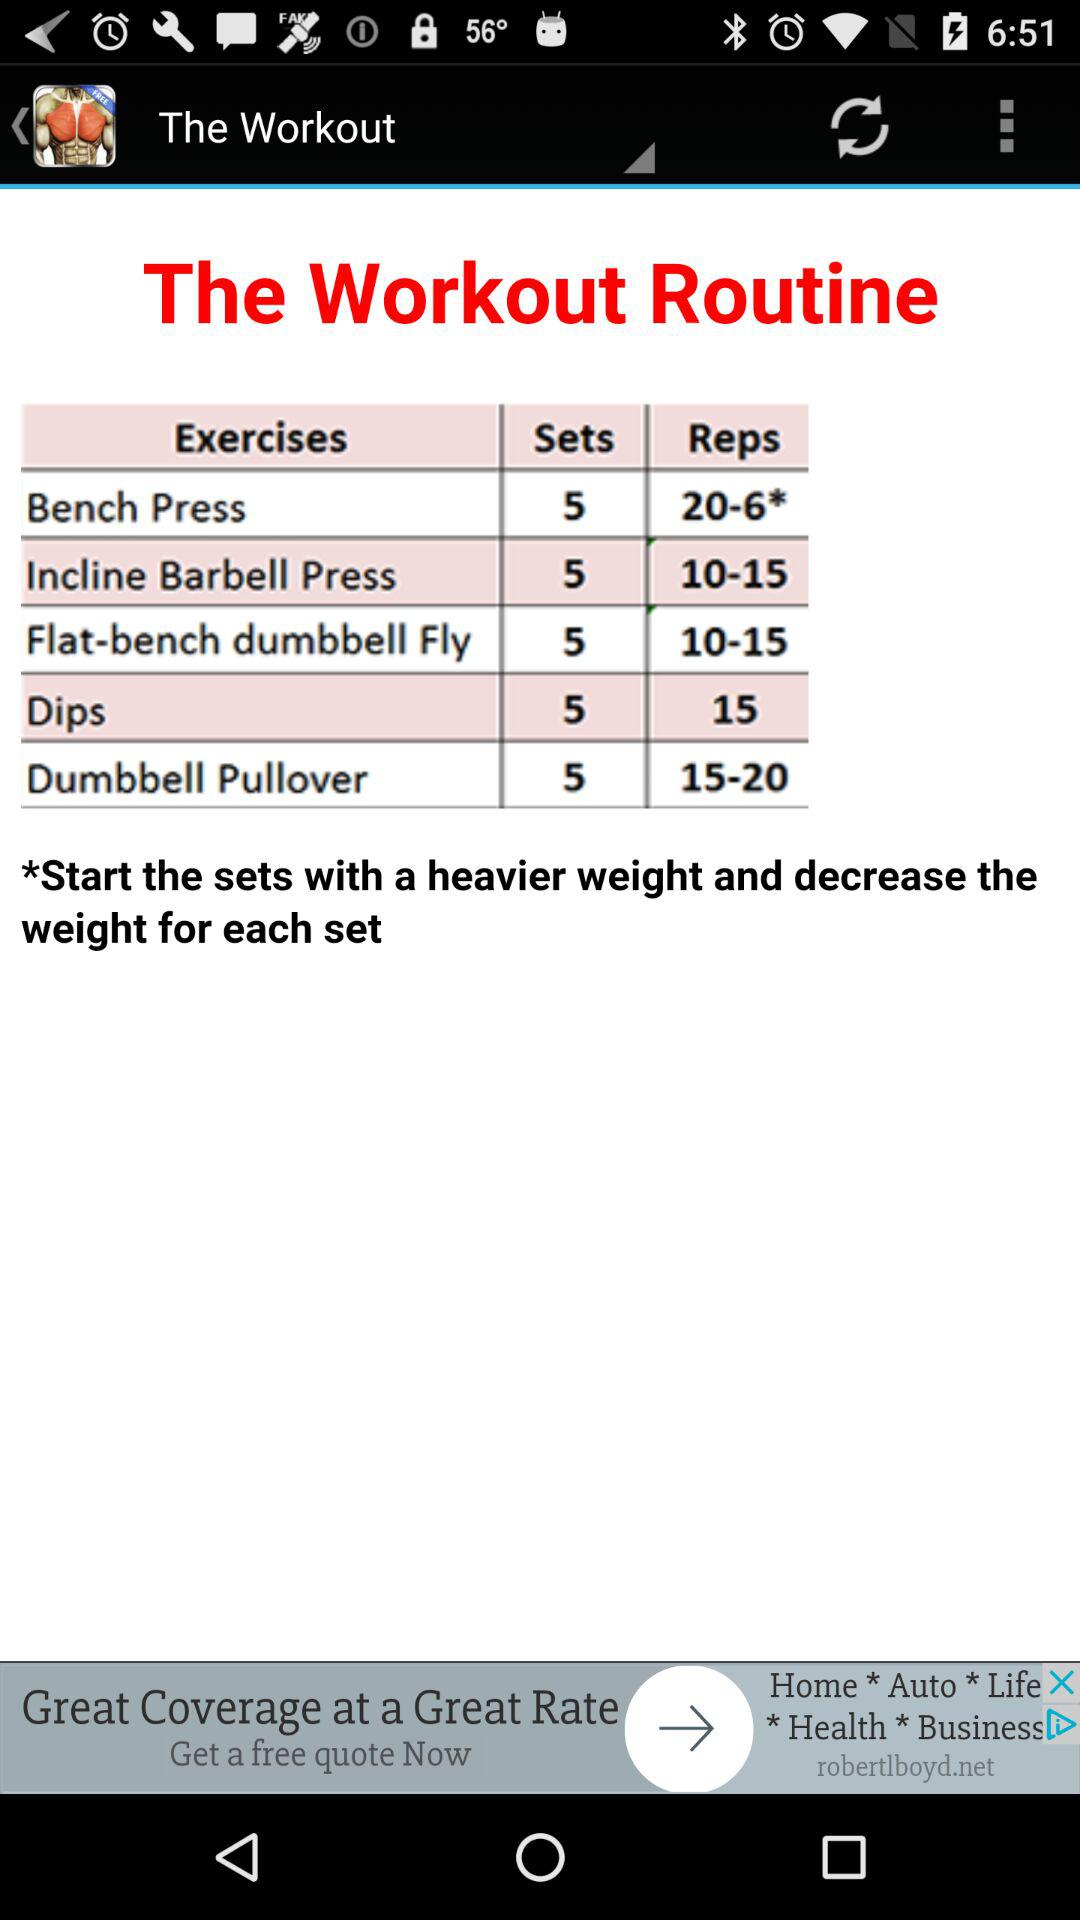What is the range of reps for Bench Press? The range of reps is 20-6. 